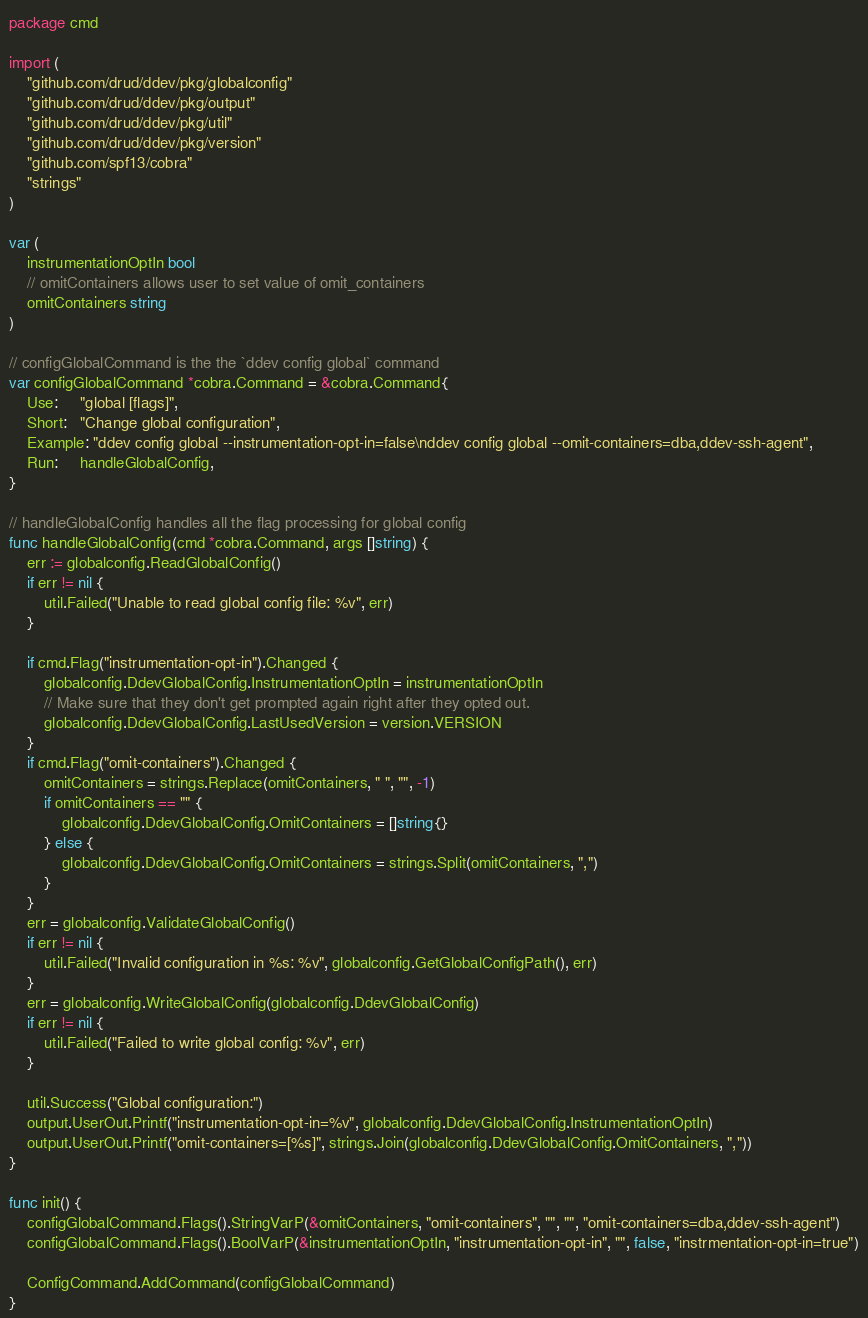<code> <loc_0><loc_0><loc_500><loc_500><_Go_>package cmd

import (
	"github.com/drud/ddev/pkg/globalconfig"
	"github.com/drud/ddev/pkg/output"
	"github.com/drud/ddev/pkg/util"
	"github.com/drud/ddev/pkg/version"
	"github.com/spf13/cobra"
	"strings"
)

var (
	instrumentationOptIn bool
	// omitContainers allows user to set value of omit_containers
	omitContainers string
)

// configGlobalCommand is the the `ddev config global` command
var configGlobalCommand *cobra.Command = &cobra.Command{
	Use:     "global [flags]",
	Short:   "Change global configuration",
	Example: "ddev config global --instrumentation-opt-in=false\nddev config global --omit-containers=dba,ddev-ssh-agent",
	Run:     handleGlobalConfig,
}

// handleGlobalConfig handles all the flag processing for global config
func handleGlobalConfig(cmd *cobra.Command, args []string) {
	err := globalconfig.ReadGlobalConfig()
	if err != nil {
		util.Failed("Unable to read global config file: %v", err)
	}

	if cmd.Flag("instrumentation-opt-in").Changed {
		globalconfig.DdevGlobalConfig.InstrumentationOptIn = instrumentationOptIn
		// Make sure that they don't get prompted again right after they opted out.
		globalconfig.DdevGlobalConfig.LastUsedVersion = version.VERSION
	}
	if cmd.Flag("omit-containers").Changed {
		omitContainers = strings.Replace(omitContainers, " ", "", -1)
		if omitContainers == "" {
			globalconfig.DdevGlobalConfig.OmitContainers = []string{}
		} else {
			globalconfig.DdevGlobalConfig.OmitContainers = strings.Split(omitContainers, ",")
		}
	}
	err = globalconfig.ValidateGlobalConfig()
	if err != nil {
		util.Failed("Invalid configuration in %s: %v", globalconfig.GetGlobalConfigPath(), err)
	}
	err = globalconfig.WriteGlobalConfig(globalconfig.DdevGlobalConfig)
	if err != nil {
		util.Failed("Failed to write global config: %v", err)
	}

	util.Success("Global configuration:")
	output.UserOut.Printf("instrumentation-opt-in=%v", globalconfig.DdevGlobalConfig.InstrumentationOptIn)
	output.UserOut.Printf("omit-containers=[%s]", strings.Join(globalconfig.DdevGlobalConfig.OmitContainers, ","))
}

func init() {
	configGlobalCommand.Flags().StringVarP(&omitContainers, "omit-containers", "", "", "omit-containers=dba,ddev-ssh-agent")
	configGlobalCommand.Flags().BoolVarP(&instrumentationOptIn, "instrumentation-opt-in", "", false, "instrmentation-opt-in=true")

	ConfigCommand.AddCommand(configGlobalCommand)
}
</code> 